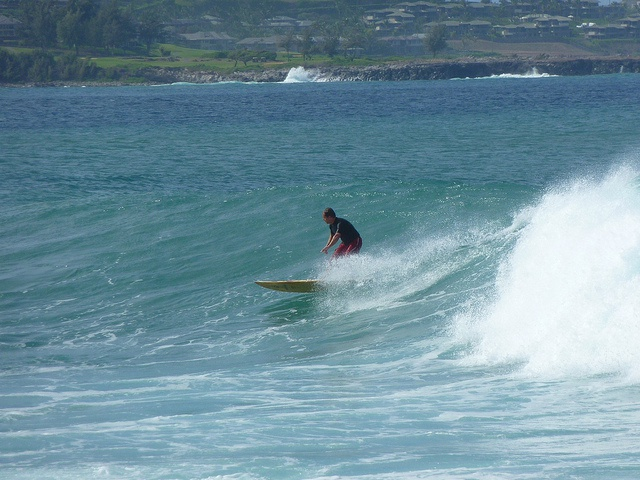Describe the objects in this image and their specific colors. I can see people in blue, black, gray, maroon, and darkgray tones and surfboard in blue, darkgreen, gray, and darkgray tones in this image. 